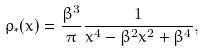Convert formula to latex. <formula><loc_0><loc_0><loc_500><loc_500>\rho _ { * } ( x ) = \frac { \beta ^ { 3 } } { \pi } \frac { 1 } { x ^ { 4 } - \beta ^ { 2 } x ^ { 2 } + \beta ^ { 4 } } ,</formula> 